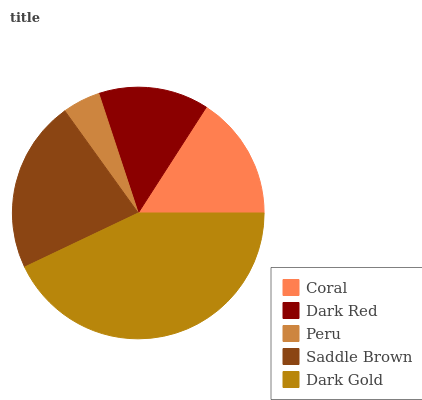Is Peru the minimum?
Answer yes or no. Yes. Is Dark Gold the maximum?
Answer yes or no. Yes. Is Dark Red the minimum?
Answer yes or no. No. Is Dark Red the maximum?
Answer yes or no. No. Is Coral greater than Dark Red?
Answer yes or no. Yes. Is Dark Red less than Coral?
Answer yes or no. Yes. Is Dark Red greater than Coral?
Answer yes or no. No. Is Coral less than Dark Red?
Answer yes or no. No. Is Coral the high median?
Answer yes or no. Yes. Is Coral the low median?
Answer yes or no. Yes. Is Dark Gold the high median?
Answer yes or no. No. Is Peru the low median?
Answer yes or no. No. 